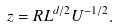Convert formula to latex. <formula><loc_0><loc_0><loc_500><loc_500>z = R L ^ { d / 2 } U ^ { - 1 / 2 } .</formula> 